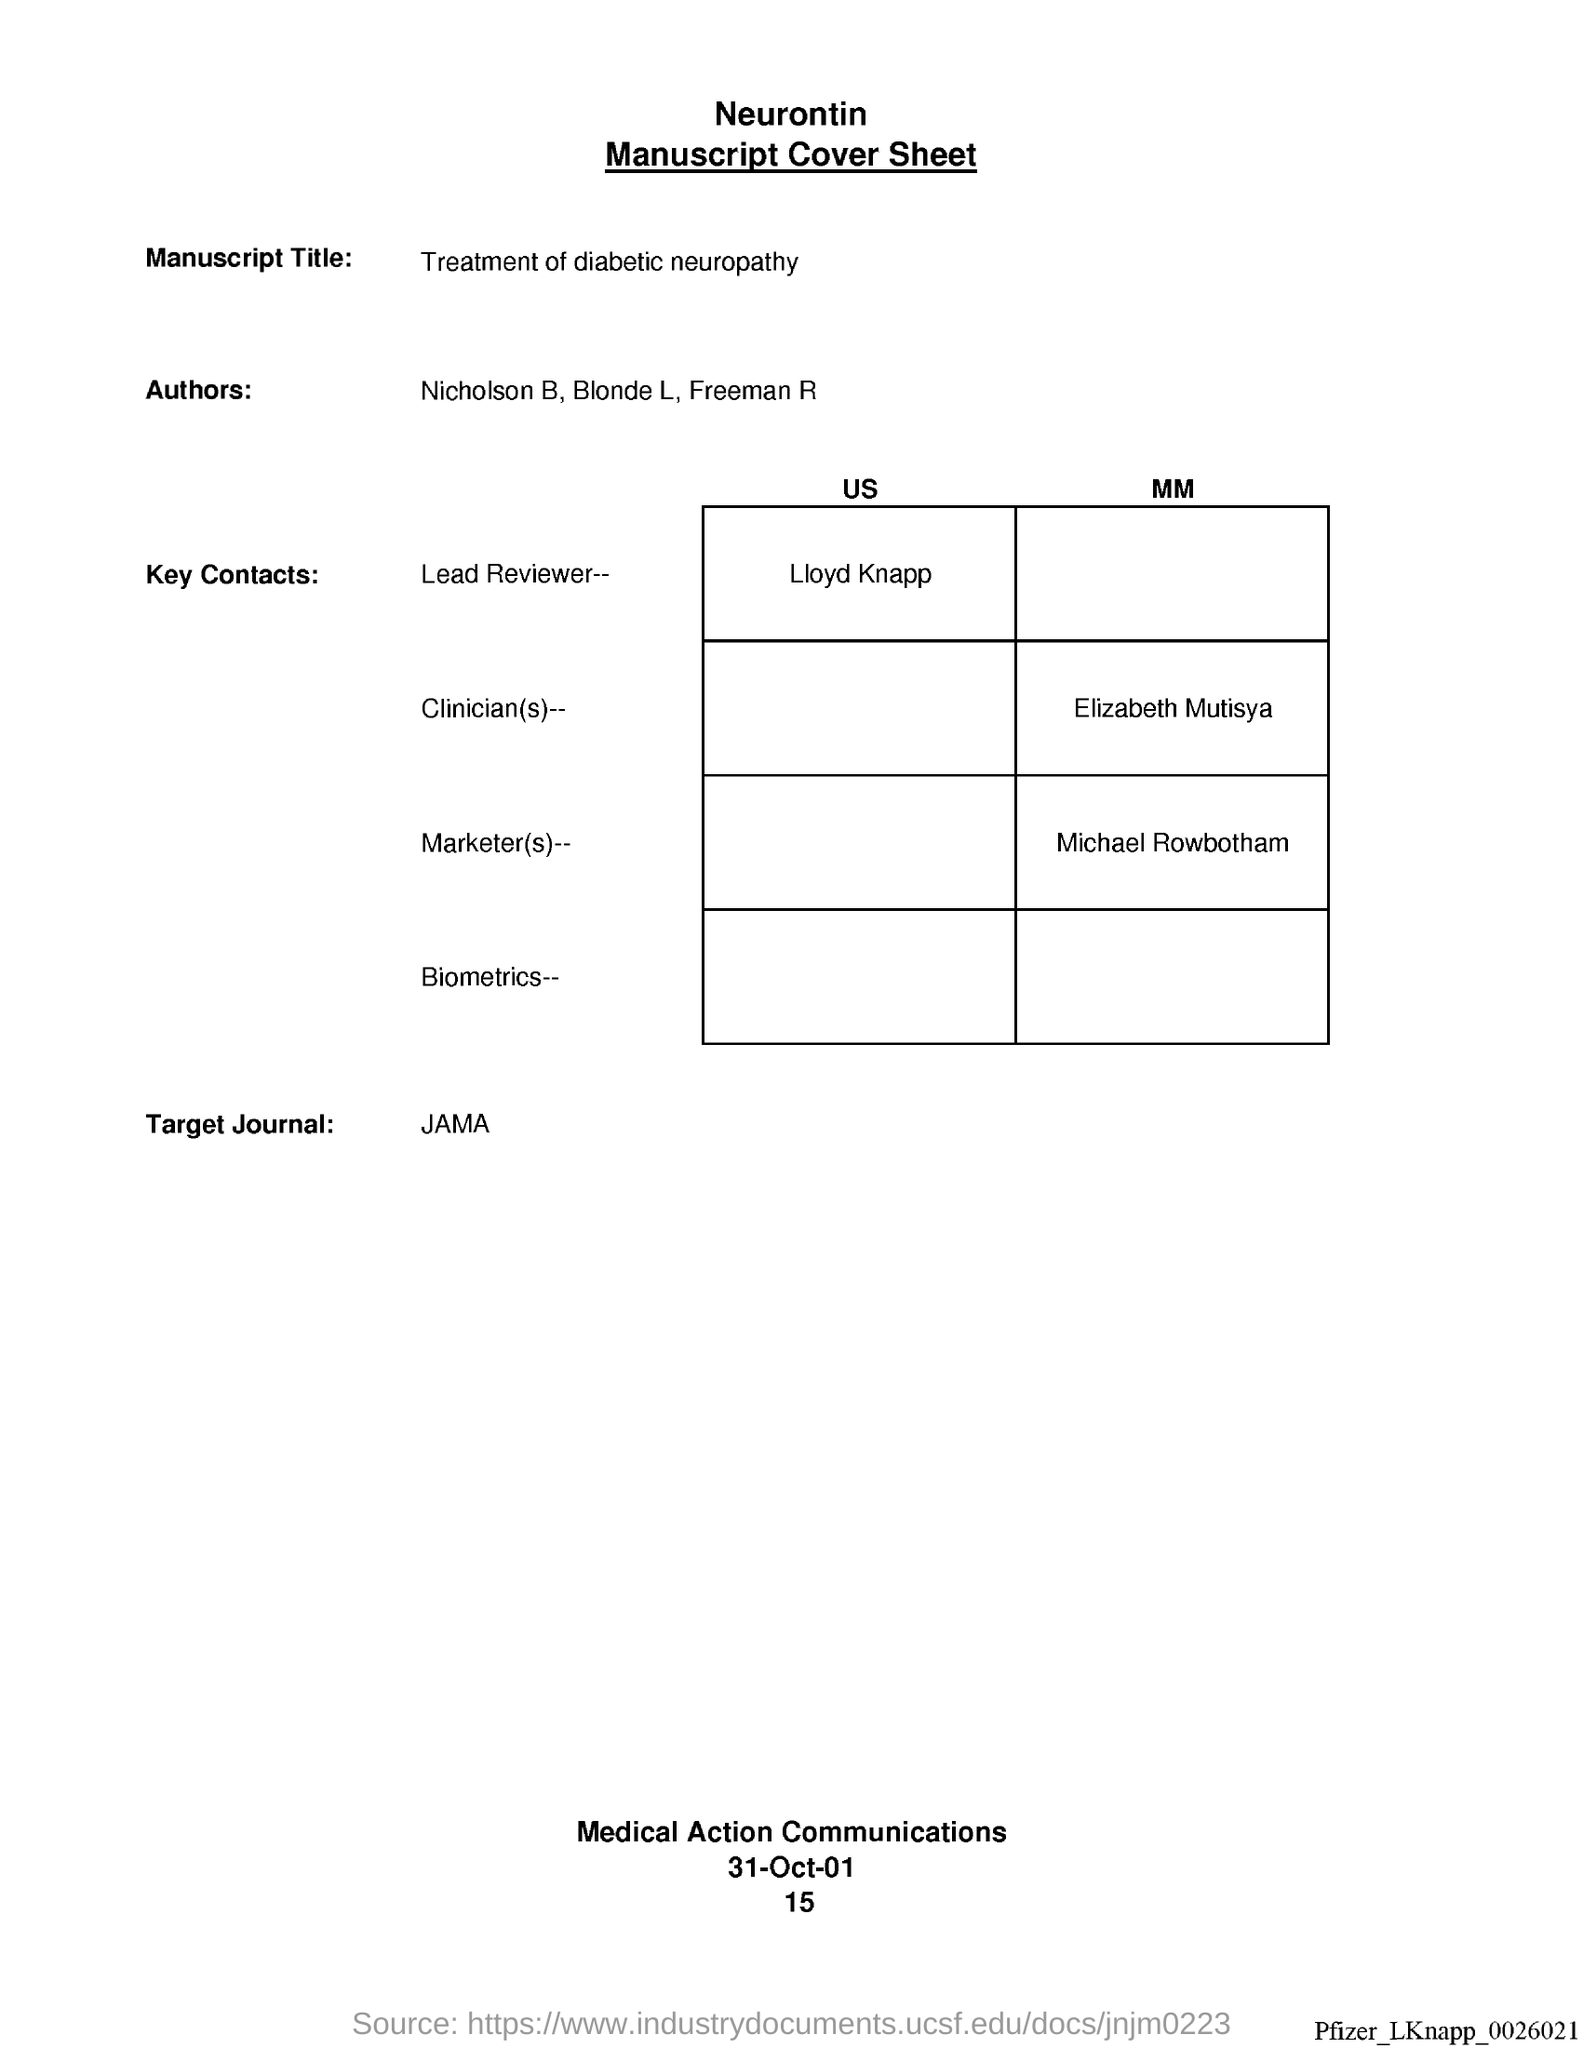What is the manuscript title ?
Provide a short and direct response. Treatment of diabetic neuropathy. Who is the lead reviewer, us?
Give a very brief answer. Lloyd knapp. Who is the clinician (s), mm?
Offer a terse response. Elizabeth Mutisya. Who is the market(s), mm?
Provide a short and direct response. Michael Rowbotham. Who is the target journal ?
Offer a very short reply. JAMA. 